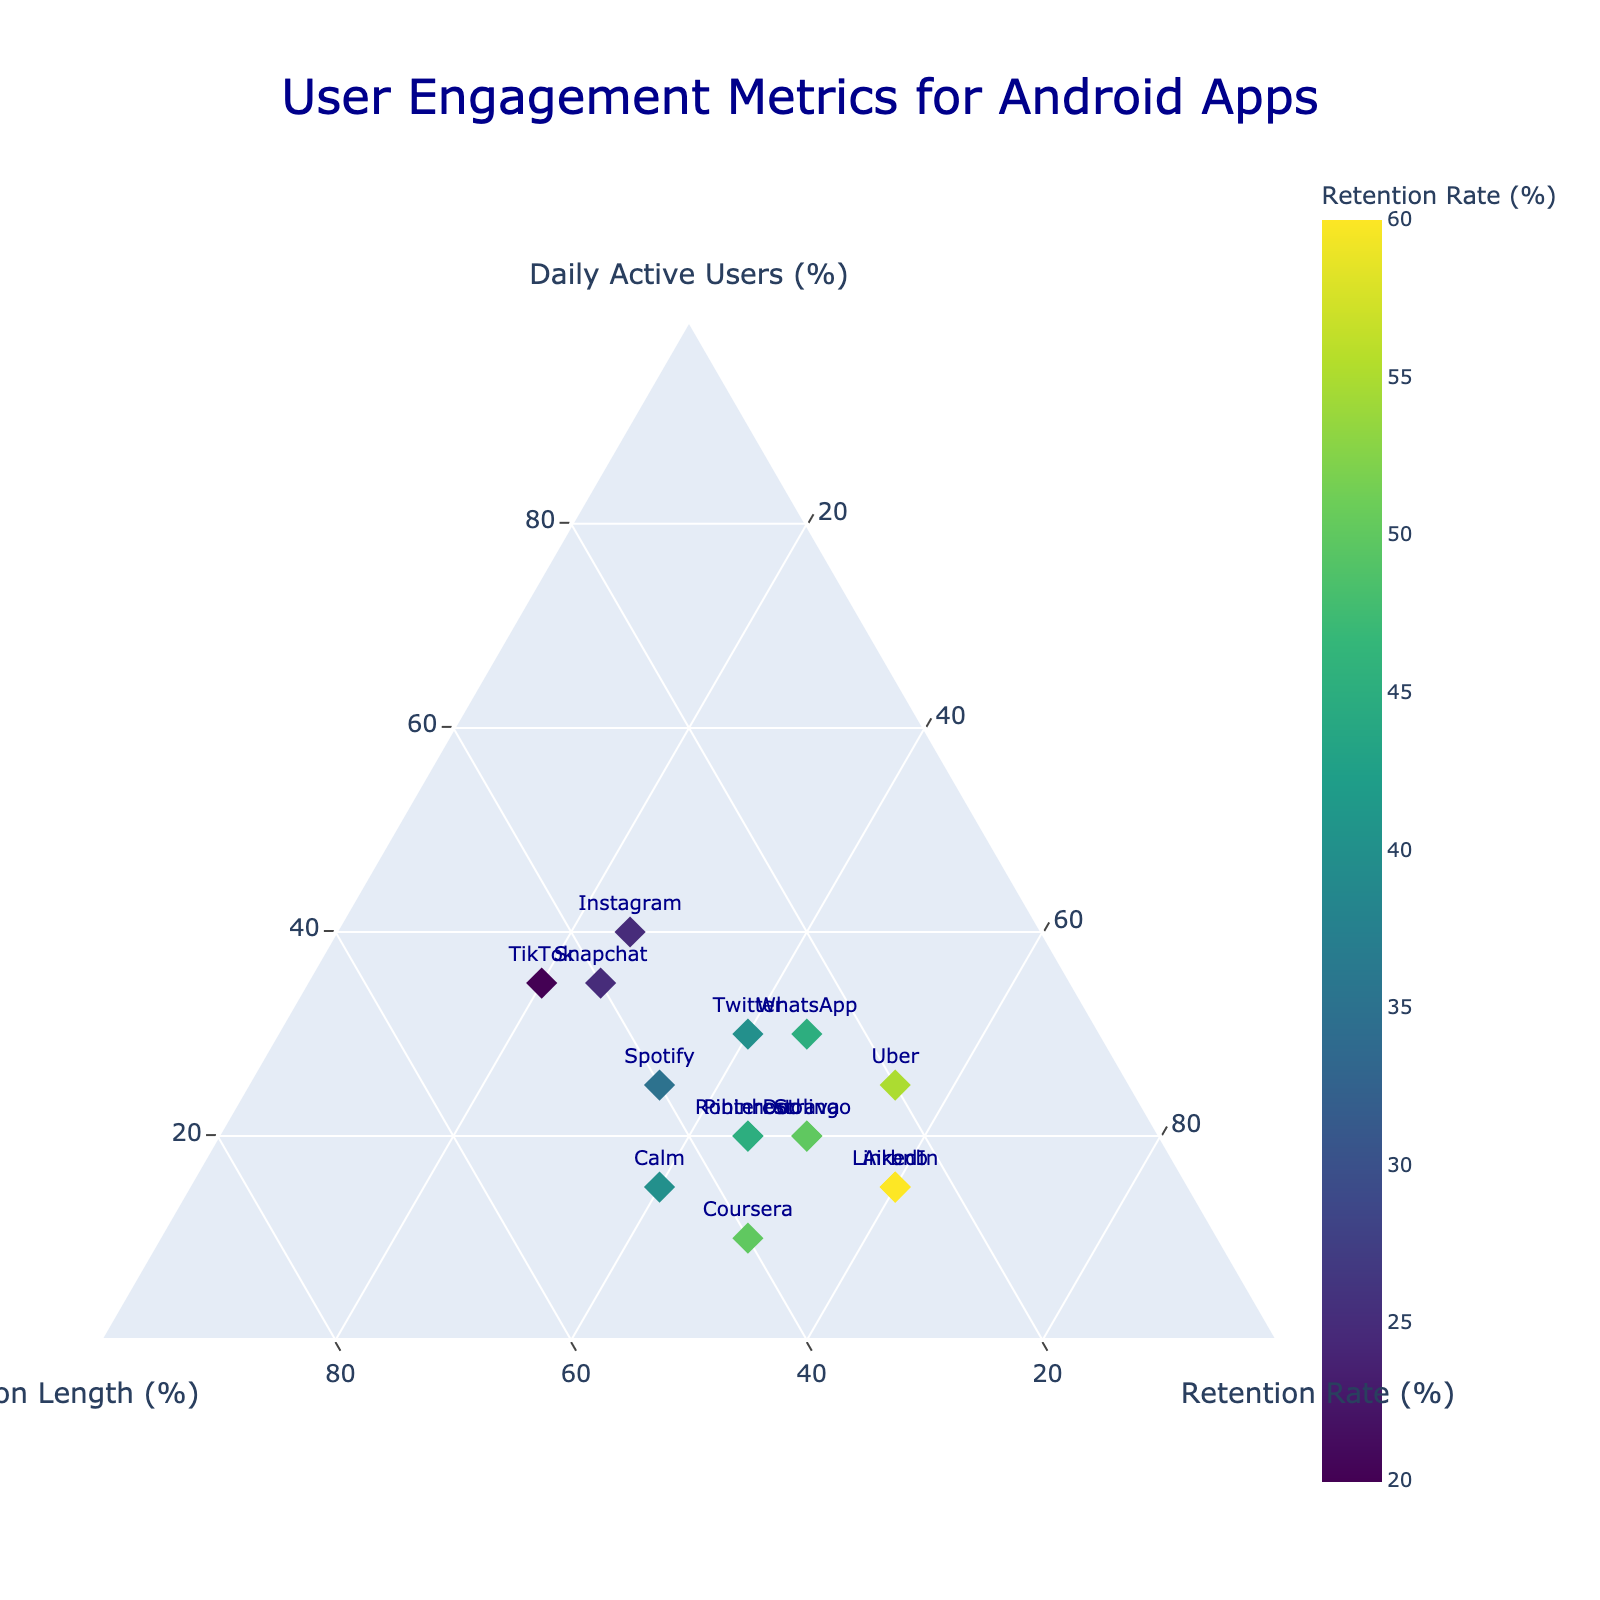How many apps have a Retention Rate (%) of at least 50%? First, identify the apps with a Retention Rate (%) of at least 50% by looking at the color and the value scale in the legend. There are four apps: Duolingo, LinkedIn, Uber, Coursera.
Answer: 4 What is the highest value on the Daily Active Users (%) axis? Look at the "Daily Active Users (%)" axis and find the maximum value marked. The highest value is 40%.
Answer: 40% Which app has the maximum Session Length (%)? Identify the app with the highest Session Length (%) by checking the data points against the "Session Length (%)" axis. The app with the maximum Session Length (%) is TikTok.
Answer: TikTok How many apps have both Daily Active Users (%) and Session Length (%) above 30%? Check the data points where both the Daily Active Users (%) and Session Length (%) values are greater than 30%. There are three such apps: Instagram, TikTok, and Snapchat.
Answer: 3 Which app shows the most balanced engagement metrics (i.e., all values closest to each other)? Find the app where the values for Daily Active Users (%), Session Length (%), and Retention Rate (%) are most similar. Uber is the most balanced with values 25, 20, and 55.
Answer: Uber Are there more apps with high Session Length (%) than high Daily Active Users (%)? To determine this, count the number of apps with Session Length (%) greater than 35% and compare it to apps with Daily Active Users (%) greater than 35%. There are more high Session Length (%) apps (6) compared to high Daily Active Users (%) apps (3).
Answer: Yes What is the most common Retention Rate (%) range in the ternary plot? Identify the range on the Retention Rate (%) colorbar where most data points fall. By observing the color distribution, the most common range is 40-50%.
Answer: 40-50% Which app is an outlier in terms of high Retention Rate (%) but low Daily Active Users (%)? Look for an app with a high Retention Rate (%) but comparatively low Daily Active Users (%). LinkedIn is an outlier with 60% Retention Rate but only 15% Daily Active Users.
Answer: LinkedIn Which app is closest to the centroid of the triangle formed by the User Engagement Metrics? Estimate the centroid of the ternary plot (where each metric would be at about 33.3%). No point exactly matches this, but Calm (15, 45, 40) is relatively close.
Answer: Calm What color is used to represent the highest Retention Rate (%) values on the plot? Identify the highest value of Retention Rate (%) on the color scale and note the corresponding color. The color for the highest Retention Rate (%) range (60%) is dark green.
Answer: Dark green 